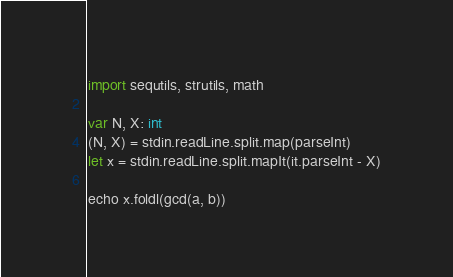Convert code to text. <code><loc_0><loc_0><loc_500><loc_500><_Nim_>import sequtils, strutils, math

var N, X: int
(N, X) = stdin.readLine.split.map(parseInt)
let x = stdin.readLine.split.mapIt(it.parseInt - X)

echo x.foldl(gcd(a, b))
</code> 